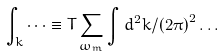<formula> <loc_0><loc_0><loc_500><loc_500>\int _ { k } \dots \equiv T \sum _ { \omega _ { m } } \int d ^ { 2 } k / \left ( 2 \pi \right ) ^ { 2 } \dots</formula> 